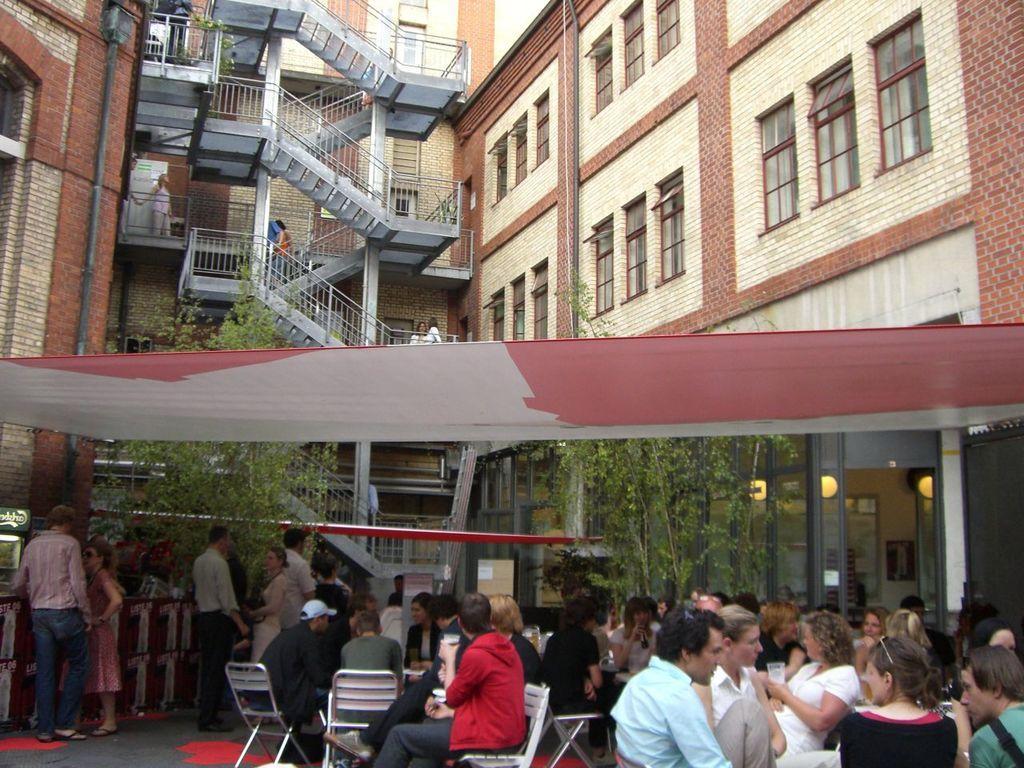Can you describe this image briefly? In this picture there are group of people sitting on the chairs under the tent. On the left side of the image there are group of people standing under the tent. At the back there is a building and there are trees and staircase and there is a pipe on the wall. 